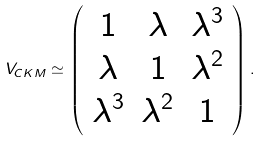Convert formula to latex. <formula><loc_0><loc_0><loc_500><loc_500>V _ { C K M } \simeq \left ( \begin{array} { c c c } { 1 } & { \lambda } & { { \lambda ^ { 3 } } } \\ { \lambda } & { 1 } & { { \lambda ^ { 2 } } } \\ { { \lambda ^ { 3 } } } & { { \lambda ^ { 2 } } } & { 1 } \end{array} \right ) .</formula> 